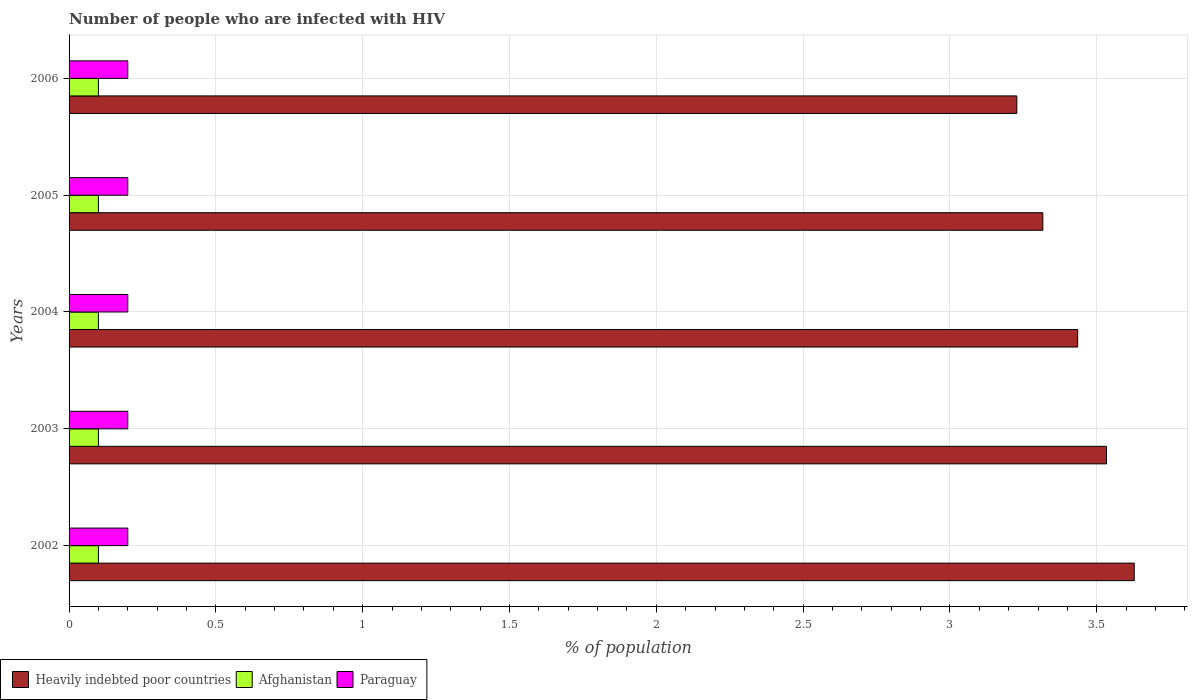How many different coloured bars are there?
Provide a short and direct response. 3. What is the label of the 5th group of bars from the top?
Keep it short and to the point. 2002. In how many cases, is the number of bars for a given year not equal to the number of legend labels?
Your answer should be very brief. 0. Across all years, what is the maximum percentage of HIV infected population in in Heavily indebted poor countries?
Give a very brief answer. 3.63. Across all years, what is the minimum percentage of HIV infected population in in Heavily indebted poor countries?
Your answer should be very brief. 3.23. In which year was the percentage of HIV infected population in in Paraguay minimum?
Provide a short and direct response. 2002. What is the total percentage of HIV infected population in in Paraguay in the graph?
Offer a terse response. 1. What is the difference between the percentage of HIV infected population in in Heavily indebted poor countries in 2004 and that in 2005?
Ensure brevity in your answer.  0.12. What is the difference between the percentage of HIV infected population in in Heavily indebted poor countries in 2006 and the percentage of HIV infected population in in Afghanistan in 2005?
Ensure brevity in your answer.  3.13. In the year 2003, what is the difference between the percentage of HIV infected population in in Afghanistan and percentage of HIV infected population in in Paraguay?
Your answer should be compact. -0.1. What is the ratio of the percentage of HIV infected population in in Heavily indebted poor countries in 2003 to that in 2005?
Your answer should be very brief. 1.07. What is the difference between the highest and the second highest percentage of HIV infected population in in Heavily indebted poor countries?
Offer a terse response. 0.09. In how many years, is the percentage of HIV infected population in in Paraguay greater than the average percentage of HIV infected population in in Paraguay taken over all years?
Your answer should be very brief. 0. Is the sum of the percentage of HIV infected population in in Paraguay in 2003 and 2004 greater than the maximum percentage of HIV infected population in in Afghanistan across all years?
Your response must be concise. Yes. What does the 3rd bar from the top in 2005 represents?
Give a very brief answer. Heavily indebted poor countries. What does the 2nd bar from the bottom in 2003 represents?
Your answer should be very brief. Afghanistan. Are all the bars in the graph horizontal?
Make the answer very short. Yes. How many years are there in the graph?
Ensure brevity in your answer.  5. What is the difference between two consecutive major ticks on the X-axis?
Keep it short and to the point. 0.5. Are the values on the major ticks of X-axis written in scientific E-notation?
Provide a succinct answer. No. Does the graph contain grids?
Your answer should be compact. Yes. Where does the legend appear in the graph?
Keep it short and to the point. Bottom left. How are the legend labels stacked?
Provide a succinct answer. Horizontal. What is the title of the graph?
Make the answer very short. Number of people who are infected with HIV. What is the label or title of the X-axis?
Provide a short and direct response. % of population. What is the % of population in Heavily indebted poor countries in 2002?
Ensure brevity in your answer.  3.63. What is the % of population of Heavily indebted poor countries in 2003?
Keep it short and to the point. 3.53. What is the % of population of Afghanistan in 2003?
Provide a short and direct response. 0.1. What is the % of population in Heavily indebted poor countries in 2004?
Make the answer very short. 3.43. What is the % of population of Afghanistan in 2004?
Ensure brevity in your answer.  0.1. What is the % of population in Heavily indebted poor countries in 2005?
Keep it short and to the point. 3.32. What is the % of population of Afghanistan in 2005?
Make the answer very short. 0.1. What is the % of population of Heavily indebted poor countries in 2006?
Provide a succinct answer. 3.23. What is the % of population of Afghanistan in 2006?
Offer a very short reply. 0.1. Across all years, what is the maximum % of population of Heavily indebted poor countries?
Your response must be concise. 3.63. Across all years, what is the maximum % of population in Afghanistan?
Give a very brief answer. 0.1. Across all years, what is the maximum % of population in Paraguay?
Make the answer very short. 0.2. Across all years, what is the minimum % of population in Heavily indebted poor countries?
Your response must be concise. 3.23. Across all years, what is the minimum % of population in Afghanistan?
Provide a short and direct response. 0.1. Across all years, what is the minimum % of population of Paraguay?
Ensure brevity in your answer.  0.2. What is the total % of population of Heavily indebted poor countries in the graph?
Ensure brevity in your answer.  17.14. What is the total % of population of Afghanistan in the graph?
Your response must be concise. 0.5. What is the difference between the % of population in Heavily indebted poor countries in 2002 and that in 2003?
Provide a short and direct response. 0.09. What is the difference between the % of population of Heavily indebted poor countries in 2002 and that in 2004?
Provide a short and direct response. 0.19. What is the difference between the % of population of Paraguay in 2002 and that in 2004?
Your response must be concise. 0. What is the difference between the % of population of Heavily indebted poor countries in 2002 and that in 2005?
Offer a very short reply. 0.31. What is the difference between the % of population in Afghanistan in 2002 and that in 2005?
Your answer should be compact. 0. What is the difference between the % of population of Heavily indebted poor countries in 2002 and that in 2006?
Your response must be concise. 0.4. What is the difference between the % of population of Afghanistan in 2002 and that in 2006?
Provide a short and direct response. 0. What is the difference between the % of population of Heavily indebted poor countries in 2003 and that in 2004?
Provide a succinct answer. 0.1. What is the difference between the % of population of Afghanistan in 2003 and that in 2004?
Offer a terse response. 0. What is the difference between the % of population of Heavily indebted poor countries in 2003 and that in 2005?
Make the answer very short. 0.22. What is the difference between the % of population of Paraguay in 2003 and that in 2005?
Your response must be concise. 0. What is the difference between the % of population of Heavily indebted poor countries in 2003 and that in 2006?
Ensure brevity in your answer.  0.31. What is the difference between the % of population in Paraguay in 2003 and that in 2006?
Offer a very short reply. 0. What is the difference between the % of population in Heavily indebted poor countries in 2004 and that in 2005?
Keep it short and to the point. 0.12. What is the difference between the % of population of Afghanistan in 2004 and that in 2005?
Offer a very short reply. 0. What is the difference between the % of population of Paraguay in 2004 and that in 2005?
Keep it short and to the point. 0. What is the difference between the % of population of Heavily indebted poor countries in 2004 and that in 2006?
Provide a succinct answer. 0.21. What is the difference between the % of population in Paraguay in 2004 and that in 2006?
Provide a short and direct response. 0. What is the difference between the % of population in Heavily indebted poor countries in 2005 and that in 2006?
Your answer should be compact. 0.09. What is the difference between the % of population of Paraguay in 2005 and that in 2006?
Your answer should be compact. 0. What is the difference between the % of population of Heavily indebted poor countries in 2002 and the % of population of Afghanistan in 2003?
Ensure brevity in your answer.  3.53. What is the difference between the % of population in Heavily indebted poor countries in 2002 and the % of population in Paraguay in 2003?
Make the answer very short. 3.43. What is the difference between the % of population of Heavily indebted poor countries in 2002 and the % of population of Afghanistan in 2004?
Provide a short and direct response. 3.53. What is the difference between the % of population of Heavily indebted poor countries in 2002 and the % of population of Paraguay in 2004?
Your response must be concise. 3.43. What is the difference between the % of population of Afghanistan in 2002 and the % of population of Paraguay in 2004?
Your answer should be very brief. -0.1. What is the difference between the % of population of Heavily indebted poor countries in 2002 and the % of population of Afghanistan in 2005?
Give a very brief answer. 3.53. What is the difference between the % of population of Heavily indebted poor countries in 2002 and the % of population of Paraguay in 2005?
Your answer should be very brief. 3.43. What is the difference between the % of population in Heavily indebted poor countries in 2002 and the % of population in Afghanistan in 2006?
Make the answer very short. 3.53. What is the difference between the % of population of Heavily indebted poor countries in 2002 and the % of population of Paraguay in 2006?
Give a very brief answer. 3.43. What is the difference between the % of population of Heavily indebted poor countries in 2003 and the % of population of Afghanistan in 2004?
Give a very brief answer. 3.43. What is the difference between the % of population in Heavily indebted poor countries in 2003 and the % of population in Paraguay in 2004?
Give a very brief answer. 3.33. What is the difference between the % of population of Heavily indebted poor countries in 2003 and the % of population of Afghanistan in 2005?
Make the answer very short. 3.43. What is the difference between the % of population of Heavily indebted poor countries in 2003 and the % of population of Paraguay in 2005?
Give a very brief answer. 3.33. What is the difference between the % of population of Afghanistan in 2003 and the % of population of Paraguay in 2005?
Give a very brief answer. -0.1. What is the difference between the % of population of Heavily indebted poor countries in 2003 and the % of population of Afghanistan in 2006?
Ensure brevity in your answer.  3.43. What is the difference between the % of population of Heavily indebted poor countries in 2003 and the % of population of Paraguay in 2006?
Provide a succinct answer. 3.33. What is the difference between the % of population in Heavily indebted poor countries in 2004 and the % of population in Afghanistan in 2005?
Your answer should be very brief. 3.33. What is the difference between the % of population in Heavily indebted poor countries in 2004 and the % of population in Paraguay in 2005?
Provide a succinct answer. 3.23. What is the difference between the % of population of Heavily indebted poor countries in 2004 and the % of population of Afghanistan in 2006?
Your response must be concise. 3.33. What is the difference between the % of population in Heavily indebted poor countries in 2004 and the % of population in Paraguay in 2006?
Make the answer very short. 3.23. What is the difference between the % of population in Heavily indebted poor countries in 2005 and the % of population in Afghanistan in 2006?
Offer a terse response. 3.22. What is the difference between the % of population of Heavily indebted poor countries in 2005 and the % of population of Paraguay in 2006?
Give a very brief answer. 3.12. What is the average % of population of Heavily indebted poor countries per year?
Ensure brevity in your answer.  3.43. What is the average % of population in Afghanistan per year?
Give a very brief answer. 0.1. What is the average % of population of Paraguay per year?
Keep it short and to the point. 0.2. In the year 2002, what is the difference between the % of population in Heavily indebted poor countries and % of population in Afghanistan?
Give a very brief answer. 3.53. In the year 2002, what is the difference between the % of population in Heavily indebted poor countries and % of population in Paraguay?
Ensure brevity in your answer.  3.43. In the year 2003, what is the difference between the % of population in Heavily indebted poor countries and % of population in Afghanistan?
Your response must be concise. 3.43. In the year 2003, what is the difference between the % of population in Heavily indebted poor countries and % of population in Paraguay?
Ensure brevity in your answer.  3.33. In the year 2004, what is the difference between the % of population in Heavily indebted poor countries and % of population in Afghanistan?
Offer a very short reply. 3.33. In the year 2004, what is the difference between the % of population of Heavily indebted poor countries and % of population of Paraguay?
Give a very brief answer. 3.23. In the year 2004, what is the difference between the % of population of Afghanistan and % of population of Paraguay?
Your answer should be very brief. -0.1. In the year 2005, what is the difference between the % of population in Heavily indebted poor countries and % of population in Afghanistan?
Ensure brevity in your answer.  3.22. In the year 2005, what is the difference between the % of population of Heavily indebted poor countries and % of population of Paraguay?
Give a very brief answer. 3.12. In the year 2005, what is the difference between the % of population of Afghanistan and % of population of Paraguay?
Ensure brevity in your answer.  -0.1. In the year 2006, what is the difference between the % of population in Heavily indebted poor countries and % of population in Afghanistan?
Make the answer very short. 3.13. In the year 2006, what is the difference between the % of population of Heavily indebted poor countries and % of population of Paraguay?
Make the answer very short. 3.03. In the year 2006, what is the difference between the % of population of Afghanistan and % of population of Paraguay?
Give a very brief answer. -0.1. What is the ratio of the % of population in Heavily indebted poor countries in 2002 to that in 2003?
Offer a very short reply. 1.03. What is the ratio of the % of population of Heavily indebted poor countries in 2002 to that in 2004?
Ensure brevity in your answer.  1.06. What is the ratio of the % of population in Afghanistan in 2002 to that in 2004?
Provide a short and direct response. 1. What is the ratio of the % of population in Paraguay in 2002 to that in 2004?
Keep it short and to the point. 1. What is the ratio of the % of population in Heavily indebted poor countries in 2002 to that in 2005?
Provide a short and direct response. 1.09. What is the ratio of the % of population of Afghanistan in 2002 to that in 2005?
Give a very brief answer. 1. What is the ratio of the % of population in Heavily indebted poor countries in 2002 to that in 2006?
Your answer should be compact. 1.12. What is the ratio of the % of population in Afghanistan in 2002 to that in 2006?
Provide a short and direct response. 1. What is the ratio of the % of population in Heavily indebted poor countries in 2003 to that in 2004?
Offer a very short reply. 1.03. What is the ratio of the % of population of Afghanistan in 2003 to that in 2004?
Make the answer very short. 1. What is the ratio of the % of population of Paraguay in 2003 to that in 2004?
Ensure brevity in your answer.  1. What is the ratio of the % of population of Heavily indebted poor countries in 2003 to that in 2005?
Keep it short and to the point. 1.07. What is the ratio of the % of population of Paraguay in 2003 to that in 2005?
Give a very brief answer. 1. What is the ratio of the % of population of Heavily indebted poor countries in 2003 to that in 2006?
Ensure brevity in your answer.  1.09. What is the ratio of the % of population in Afghanistan in 2003 to that in 2006?
Ensure brevity in your answer.  1. What is the ratio of the % of population of Paraguay in 2003 to that in 2006?
Give a very brief answer. 1. What is the ratio of the % of population of Heavily indebted poor countries in 2004 to that in 2005?
Offer a terse response. 1.04. What is the ratio of the % of population of Paraguay in 2004 to that in 2005?
Give a very brief answer. 1. What is the ratio of the % of population of Heavily indebted poor countries in 2004 to that in 2006?
Keep it short and to the point. 1.06. What is the ratio of the % of population in Heavily indebted poor countries in 2005 to that in 2006?
Give a very brief answer. 1.03. What is the ratio of the % of population of Paraguay in 2005 to that in 2006?
Offer a very short reply. 1. What is the difference between the highest and the second highest % of population in Heavily indebted poor countries?
Offer a terse response. 0.09. What is the difference between the highest and the second highest % of population of Afghanistan?
Your response must be concise. 0. What is the difference between the highest and the second highest % of population in Paraguay?
Provide a short and direct response. 0. What is the difference between the highest and the lowest % of population of Heavily indebted poor countries?
Your answer should be very brief. 0.4. What is the difference between the highest and the lowest % of population in Afghanistan?
Provide a short and direct response. 0. What is the difference between the highest and the lowest % of population in Paraguay?
Your response must be concise. 0. 